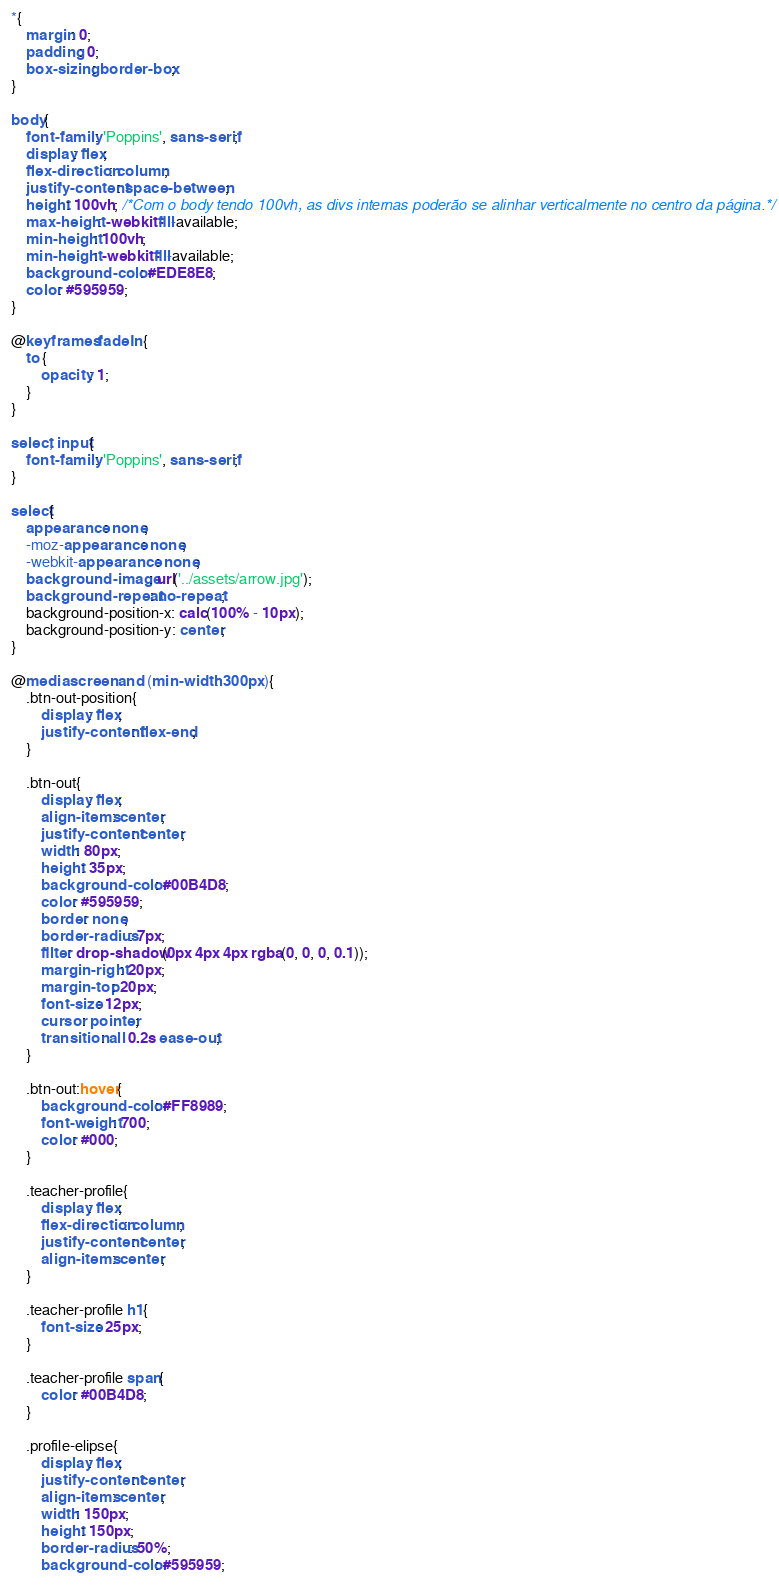Convert code to text. <code><loc_0><loc_0><loc_500><loc_500><_CSS_>*{
    margin: 0;
    padding: 0;
    box-sizing: border-box;
}

body{
    font-family: 'Poppins', sans-serif;
    display: flex;
    flex-direction: column;
    justify-content: space-between;
    height: 100vh; /*Com o body tendo 100vh, as divs internas poderão se alinhar verticalmente no centro da página.*/
    max-height: -webkit-fill-available;
    min-height: 100vh;
    min-height: -webkit-fill-available;
    background-color: #EDE8E8;
    color: #595959;
}  

@keyframes fadeIn {
    to {
        opacity: 1;
    }
}

select, input{
    font-family: 'Poppins', sans-serif;
}

select{
    appearance: none;
    -moz-appearance: none;
    -webkit-appearance: none;
    background-image: url('../assets/arrow.jpg');
    background-repeat: no-repeat;
    background-position-x: calc(100% - 10px);
    background-position-y: center;
}

@media screen and (min-width: 300px){
    .btn-out-position{
        display: flex;
        justify-content: flex-end;
    }
    
    .btn-out{
        display: flex;
        align-items: center;
        justify-content: center;
        width: 80px;
        height: 35px;
        background-color: #00B4D8;
        color: #595959;
        border: none;
        border-radius: 7px;
        filter: drop-shadow(0px 4px 4px rgba(0, 0, 0, 0.1));
        margin-right: 20px;
        margin-top: 20px;
        font-size: 12px;
        cursor: pointer;
        transition: all 0.2s ease-out;
    }
    
    .btn-out:hover{
        background-color: #FF8989;
        font-weight: 700;
        color: #000;
    }
    
    .teacher-profile{
        display: flex;
        flex-direction: column;
        justify-content: center;
        align-items: center;
    }

    .teacher-profile h1{
        font-size: 25px;
    }
    
    .teacher-profile span{
        color: #00B4D8;
    }
    
    .profile-elipse{
        display: flex;
        justify-content: center;
        align-items: center;
        width: 150px;
        height: 150px;
        border-radius: 50%;
        background-color: #595959;</code> 